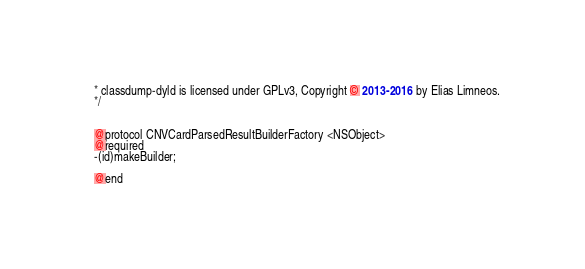Convert code to text. <code><loc_0><loc_0><loc_500><loc_500><_C_>* classdump-dyld is licensed under GPLv3, Copyright © 2013-2016 by Elias Limneos.
*/


@protocol CNVCardParsedResultBuilderFactory <NSObject>
@required
-(id)makeBuilder;

@end

</code> 